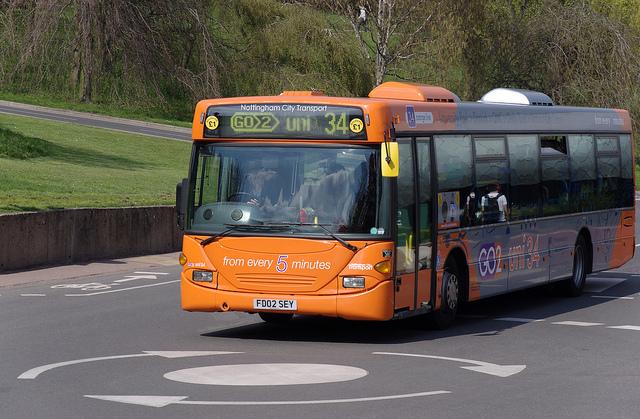Are there arrows?
Be succinct. Yes. What number is on the top right of the bus?
Quick response, please. 34. What color is the bus?
Be succinct. Orange. 